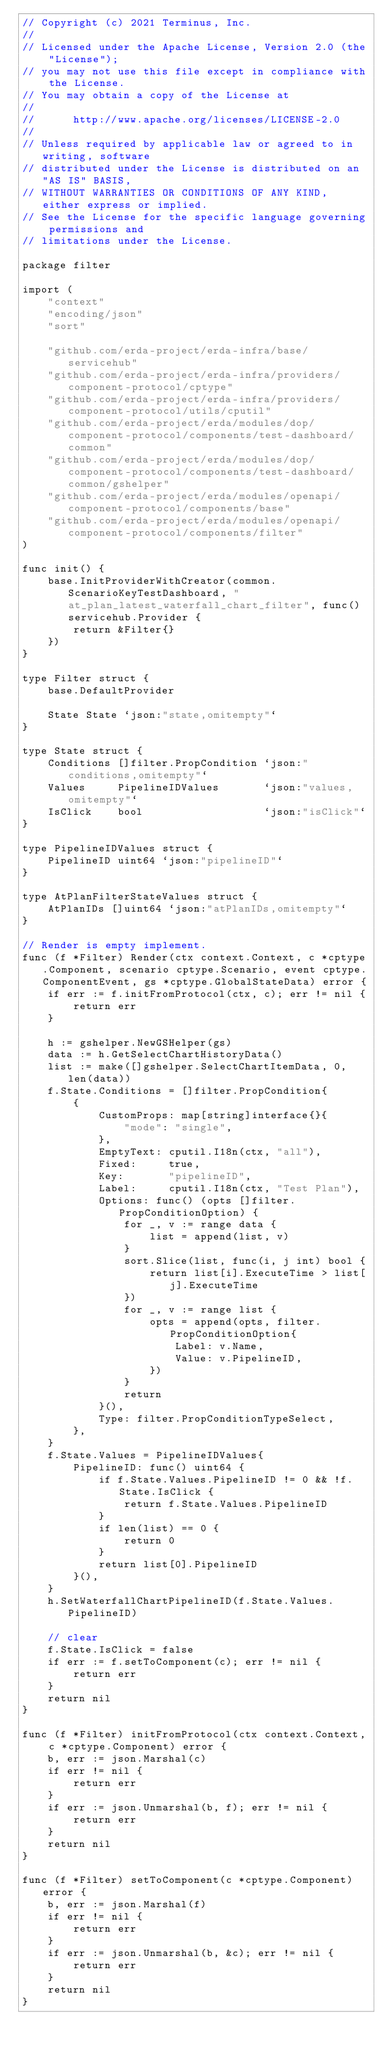<code> <loc_0><loc_0><loc_500><loc_500><_Go_>// Copyright (c) 2021 Terminus, Inc.
//
// Licensed under the Apache License, Version 2.0 (the "License");
// you may not use this file except in compliance with the License.
// You may obtain a copy of the License at
//
//      http://www.apache.org/licenses/LICENSE-2.0
//
// Unless required by applicable law or agreed to in writing, software
// distributed under the License is distributed on an "AS IS" BASIS,
// WITHOUT WARRANTIES OR CONDITIONS OF ANY KIND, either express or implied.
// See the License for the specific language governing permissions and
// limitations under the License.

package filter

import (
	"context"
	"encoding/json"
	"sort"

	"github.com/erda-project/erda-infra/base/servicehub"
	"github.com/erda-project/erda-infra/providers/component-protocol/cptype"
	"github.com/erda-project/erda-infra/providers/component-protocol/utils/cputil"
	"github.com/erda-project/erda/modules/dop/component-protocol/components/test-dashboard/common"
	"github.com/erda-project/erda/modules/dop/component-protocol/components/test-dashboard/common/gshelper"
	"github.com/erda-project/erda/modules/openapi/component-protocol/components/base"
	"github.com/erda-project/erda/modules/openapi/component-protocol/components/filter"
)

func init() {
	base.InitProviderWithCreator(common.ScenarioKeyTestDashboard, "at_plan_latest_waterfall_chart_filter", func() servicehub.Provider {
		return &Filter{}
	})
}

type Filter struct {
	base.DefaultProvider

	State State `json:"state,omitempty"`
}

type State struct {
	Conditions []filter.PropCondition `json:"conditions,omitempty"`
	Values     PipelineIDValues       `json:"values,omitempty"`
	IsClick    bool                   `json:"isClick"`
}

type PipelineIDValues struct {
	PipelineID uint64 `json:"pipelineID"`
}

type AtPlanFilterStateValues struct {
	AtPlanIDs []uint64 `json:"atPlanIDs,omitempty"`
}

// Render is empty implement.
func (f *Filter) Render(ctx context.Context, c *cptype.Component, scenario cptype.Scenario, event cptype.ComponentEvent, gs *cptype.GlobalStateData) error {
	if err := f.initFromProtocol(ctx, c); err != nil {
		return err
	}

	h := gshelper.NewGSHelper(gs)
	data := h.GetSelectChartHistoryData()
	list := make([]gshelper.SelectChartItemData, 0, len(data))
	f.State.Conditions = []filter.PropCondition{
		{
			CustomProps: map[string]interface{}{
				"mode": "single",
			},
			EmptyText: cputil.I18n(ctx, "all"),
			Fixed:     true,
			Key:       "pipelineID",
			Label:     cputil.I18n(ctx, "Test Plan"),
			Options: func() (opts []filter.PropConditionOption) {
				for _, v := range data {
					list = append(list, v)
				}
				sort.Slice(list, func(i, j int) bool {
					return list[i].ExecuteTime > list[j].ExecuteTime
				})
				for _, v := range list {
					opts = append(opts, filter.PropConditionOption{
						Label: v.Name,
						Value: v.PipelineID,
					})
				}
				return
			}(),
			Type: filter.PropConditionTypeSelect,
		},
	}
	f.State.Values = PipelineIDValues{
		PipelineID: func() uint64 {
			if f.State.Values.PipelineID != 0 && !f.State.IsClick {
				return f.State.Values.PipelineID
			}
			if len(list) == 0 {
				return 0
			}
			return list[0].PipelineID
		}(),
	}
	h.SetWaterfallChartPipelineID(f.State.Values.PipelineID)

	// clear
	f.State.IsClick = false
	if err := f.setToComponent(c); err != nil {
		return err
	}
	return nil
}

func (f *Filter) initFromProtocol(ctx context.Context, c *cptype.Component) error {
	b, err := json.Marshal(c)
	if err != nil {
		return err
	}
	if err := json.Unmarshal(b, f); err != nil {
		return err
	}
	return nil
}

func (f *Filter) setToComponent(c *cptype.Component) error {
	b, err := json.Marshal(f)
	if err != nil {
		return err
	}
	if err := json.Unmarshal(b, &c); err != nil {
		return err
	}
	return nil
}
</code> 